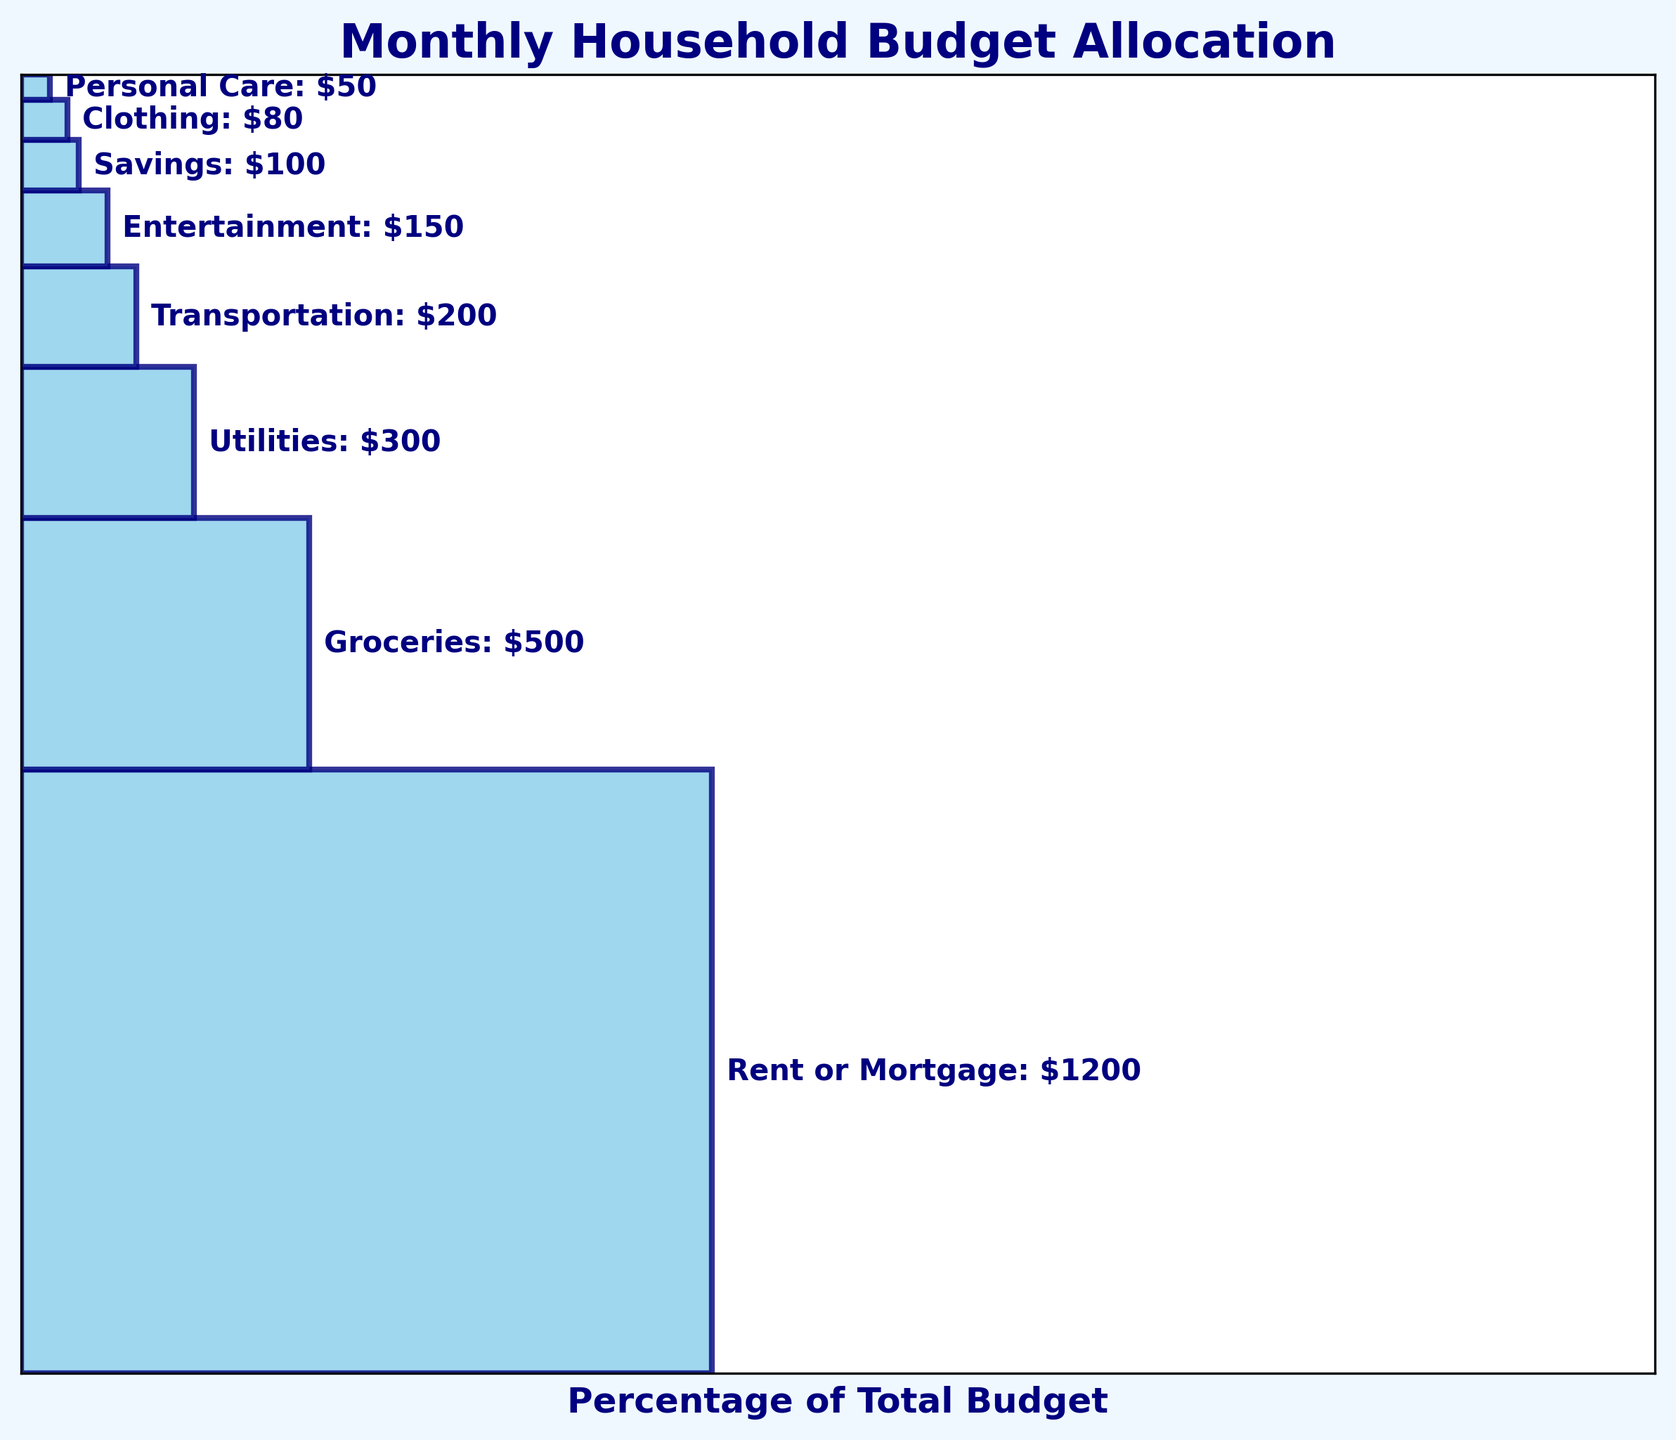What is the title of the figure? The title is displayed at the top of the figure in a large, bold font. It usually summarizes what the chart is representing.
Answer: Monthly Household Budget Allocation Which expense category has the highest allocation? The highest section in the funnel chart corresponds to the category with the largest amount.
Answer: Rent or Mortgage How much percentage of the total budget is allocated to Groceries? The width of the Groceries section represents its percentage of the total budget.
Answer: 21.93% What is the combined amount allocated to Entertainment and Personal Care? The amounts for Entertainment and Personal Care are $150 and $50 respectively. Adding them together gives $150 + $50 = $200.
Answer: $200 Which category has a larger budget allocation: Transportation or Clothing? By comparing the sections of Transportation and Clothing, it's evident which one is larger. Transportation's section is wider.
Answer: Transportation What is the total amount allocated to utilities, savings, and personal care? The amounts for Utilities, Savings, and Personal Care are $300, $100, and $50 respectively. Adding them together gives $300 + $100 + $50 = $450.
Answer: $450 Which category has the smallest allocation, and what is its percentage of the total budget? The smallest section at the bottom of the funnel represents the category with the smallest amount. Calculating its percentage involves dividing its amount by the total budget and multiplying by 100.
Answer: Personal Care, 2.56% How does the amount allocated to Groceries compare to Rent or Mortgage? By comparing the widths of the sections for Groceries and Rent or Mortgage, it's clear that Groceries has a significantly smaller allocation. The exact amounts can be compared directly ($500 vs $1200).
Answer: Groceries is smaller What fraction of the budget is allocated to Transportation? The Transportation section's width represents its fraction of the total budget. Convert it into a precise fraction: $200/$2580.
Answer: 7.75% What is the average allocation amount for all categories? Calculate the total budget and divide by the number of categories: The total sum is $2580, and there are 8 categories, so $2580/8.
Answer: $322.50 